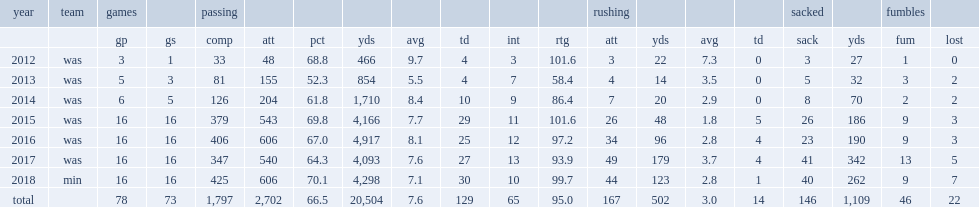How many passing touchdowns did kirk cousins get in 2015? 29.0. 